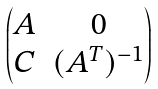<formula> <loc_0><loc_0><loc_500><loc_500>\begin{pmatrix} A & 0 \\ C & ( A ^ { T } ) ^ { - 1 } \end{pmatrix}</formula> 